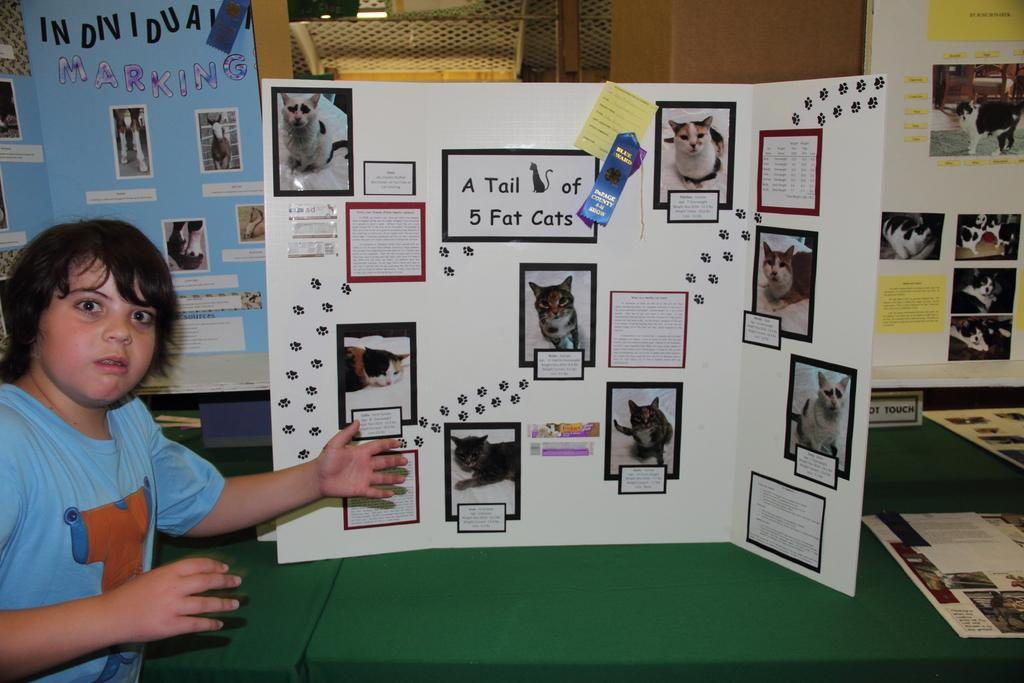Provide a one-sentence caption for the provided image. a boy in front of a poster titled A Tail of 5 Fat Cats. 